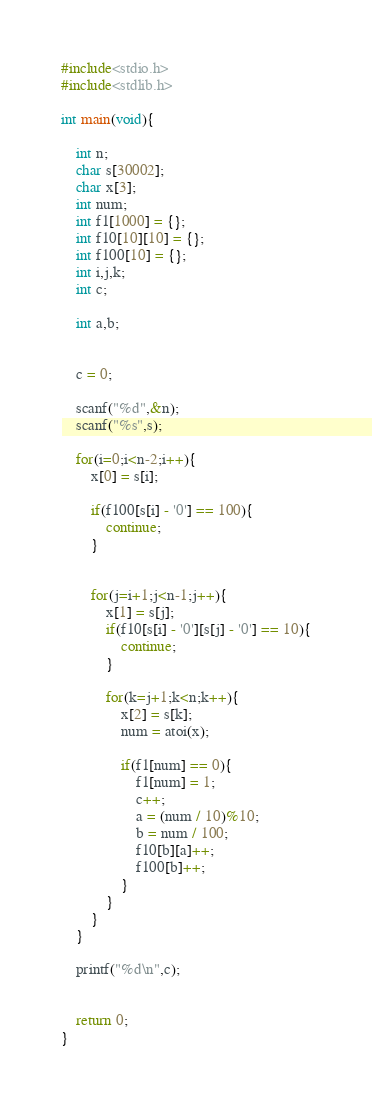<code> <loc_0><loc_0><loc_500><loc_500><_C++_>#include<stdio.h>
#include<stdlib.h>

int main(void){

	int n;
	char s[30002];
	char x[3];
	int num;
	int f1[1000] = {};
	int f10[10][10] = {};
	int f100[10] = {};
	int i,j,k;
	int c;

	int a,b;


	c = 0;

	scanf("%d",&n);
	scanf("%s",s);

	for(i=0;i<n-2;i++){
		x[0] = s[i];

		if(f100[s[i] - '0'] == 100){
			continue;
		}


		for(j=i+1;j<n-1;j++){
			x[1] = s[j];
			if(f10[s[i] - '0'][s[j] - '0'] == 10){
				continue;
			}

			for(k=j+1;k<n;k++){
				x[2] = s[k];
				num = atoi(x);

				if(f1[num] == 0){
					f1[num] = 1;
					c++;
					a = (num / 10)%10;
					b = num / 100;
					f10[b][a]++;
					f100[b]++;
				}
			}
		}
	}

	printf("%d\n",c);


	return 0;
}

</code> 